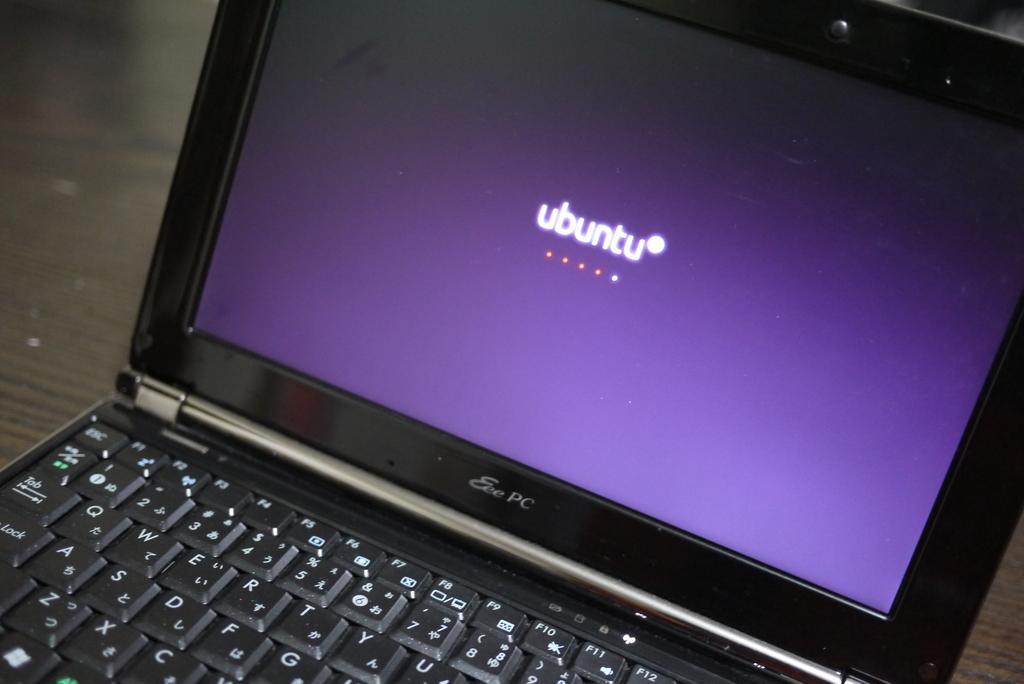Please provide a concise description of this image. This image consists of a laptop in black color is kept on a table. 